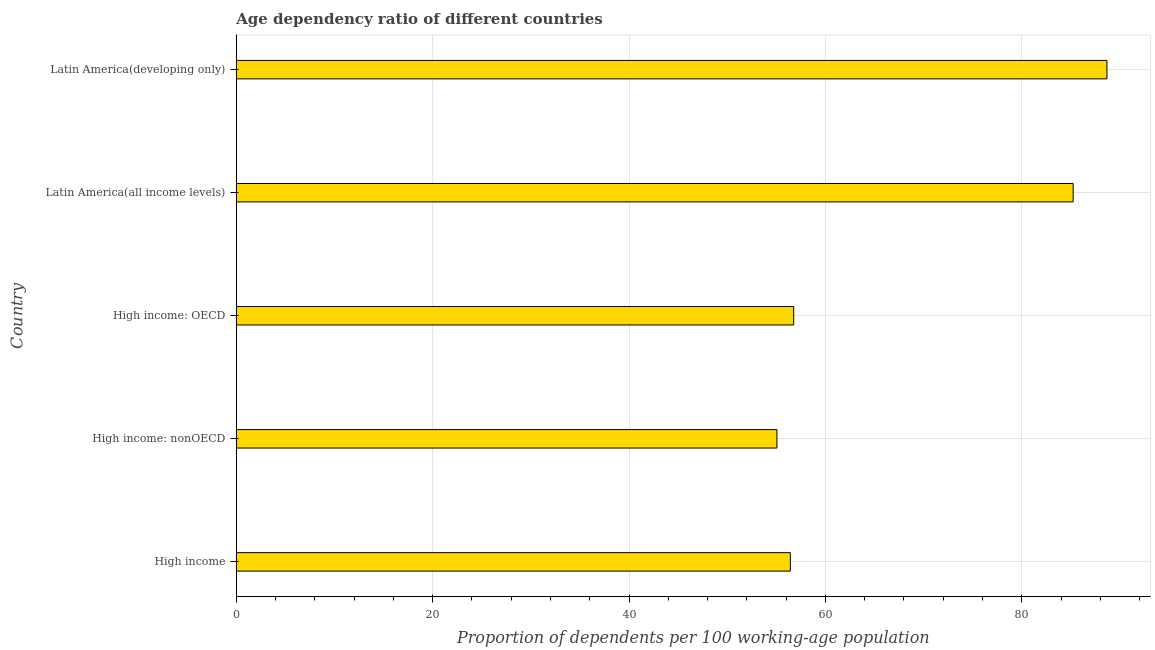What is the title of the graph?
Provide a succinct answer. Age dependency ratio of different countries. What is the label or title of the X-axis?
Provide a succinct answer. Proportion of dependents per 100 working-age population. What is the label or title of the Y-axis?
Your answer should be very brief. Country. What is the age dependency ratio in High income: OECD?
Offer a terse response. 56.77. Across all countries, what is the maximum age dependency ratio?
Give a very brief answer. 88.67. Across all countries, what is the minimum age dependency ratio?
Ensure brevity in your answer.  55.06. In which country was the age dependency ratio maximum?
Provide a short and direct response. Latin America(developing only). In which country was the age dependency ratio minimum?
Ensure brevity in your answer.  High income: nonOECD. What is the sum of the age dependency ratio?
Ensure brevity in your answer.  342.16. What is the difference between the age dependency ratio in High income: nonOECD and Latin America(developing only)?
Ensure brevity in your answer.  -33.61. What is the average age dependency ratio per country?
Keep it short and to the point. 68.43. What is the median age dependency ratio?
Your answer should be compact. 56.77. In how many countries, is the age dependency ratio greater than 32 ?
Ensure brevity in your answer.  5. What is the difference between the highest and the second highest age dependency ratio?
Your answer should be compact. 3.44. Is the sum of the age dependency ratio in High income: nonOECD and Latin America(all income levels) greater than the maximum age dependency ratio across all countries?
Offer a very short reply. Yes. What is the difference between the highest and the lowest age dependency ratio?
Provide a succinct answer. 33.61. In how many countries, is the age dependency ratio greater than the average age dependency ratio taken over all countries?
Keep it short and to the point. 2. Are the values on the major ticks of X-axis written in scientific E-notation?
Ensure brevity in your answer.  No. What is the Proportion of dependents per 100 working-age population in High income?
Offer a very short reply. 56.43. What is the Proportion of dependents per 100 working-age population of High income: nonOECD?
Provide a succinct answer. 55.06. What is the Proportion of dependents per 100 working-age population in High income: OECD?
Your answer should be very brief. 56.77. What is the Proportion of dependents per 100 working-age population of Latin America(all income levels)?
Your answer should be very brief. 85.23. What is the Proportion of dependents per 100 working-age population of Latin America(developing only)?
Your response must be concise. 88.67. What is the difference between the Proportion of dependents per 100 working-age population in High income and High income: nonOECD?
Give a very brief answer. 1.37. What is the difference between the Proportion of dependents per 100 working-age population in High income and High income: OECD?
Provide a succinct answer. -0.34. What is the difference between the Proportion of dependents per 100 working-age population in High income and Latin America(all income levels)?
Provide a succinct answer. -28.8. What is the difference between the Proportion of dependents per 100 working-age population in High income and Latin America(developing only)?
Provide a succinct answer. -32.24. What is the difference between the Proportion of dependents per 100 working-age population in High income: nonOECD and High income: OECD?
Offer a terse response. -1.71. What is the difference between the Proportion of dependents per 100 working-age population in High income: nonOECD and Latin America(all income levels)?
Give a very brief answer. -30.17. What is the difference between the Proportion of dependents per 100 working-age population in High income: nonOECD and Latin America(developing only)?
Keep it short and to the point. -33.61. What is the difference between the Proportion of dependents per 100 working-age population in High income: OECD and Latin America(all income levels)?
Offer a terse response. -28.46. What is the difference between the Proportion of dependents per 100 working-age population in High income: OECD and Latin America(developing only)?
Your answer should be compact. -31.9. What is the difference between the Proportion of dependents per 100 working-age population in Latin America(all income levels) and Latin America(developing only)?
Provide a short and direct response. -3.44. What is the ratio of the Proportion of dependents per 100 working-age population in High income to that in High income: nonOECD?
Provide a succinct answer. 1.02. What is the ratio of the Proportion of dependents per 100 working-age population in High income to that in Latin America(all income levels)?
Provide a short and direct response. 0.66. What is the ratio of the Proportion of dependents per 100 working-age population in High income to that in Latin America(developing only)?
Provide a succinct answer. 0.64. What is the ratio of the Proportion of dependents per 100 working-age population in High income: nonOECD to that in High income: OECD?
Offer a very short reply. 0.97. What is the ratio of the Proportion of dependents per 100 working-age population in High income: nonOECD to that in Latin America(all income levels)?
Provide a succinct answer. 0.65. What is the ratio of the Proportion of dependents per 100 working-age population in High income: nonOECD to that in Latin America(developing only)?
Offer a very short reply. 0.62. What is the ratio of the Proportion of dependents per 100 working-age population in High income: OECD to that in Latin America(all income levels)?
Your answer should be very brief. 0.67. What is the ratio of the Proportion of dependents per 100 working-age population in High income: OECD to that in Latin America(developing only)?
Make the answer very short. 0.64. What is the ratio of the Proportion of dependents per 100 working-age population in Latin America(all income levels) to that in Latin America(developing only)?
Keep it short and to the point. 0.96. 